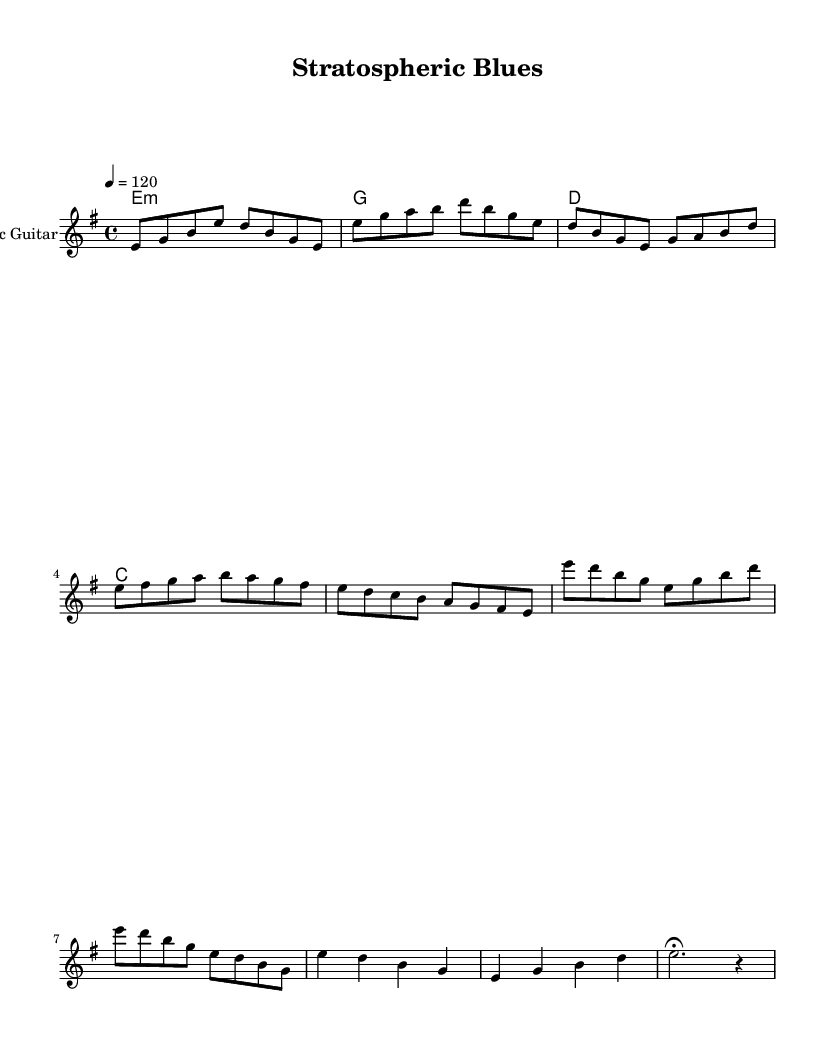What is the key signature of this music? The key signature is identified by the notes within the music. Here, the key signature is indicated as E minor, typically signified by one sharp (F#) that is often implied rather than explicitly stated in the music.
Answer: E minor What is the time signature of this music? The time signature can be identified at the beginning of the sheet music, indicated by the numbers showing how many beats are in each measure, which in this case is 4 over 4, meaning there are four beats per measure.
Answer: 4/4 What is the tempo marking for this piece? The tempo marking is stated as "4 = 120," which indicates that the quarter note gets a beat and the tempo is set at 120 beats per minute, providing a moderately fast pace for the piece.
Answer: 120 How many measures are in the first solo? By counting the measures in the first solo section, we see it consists of four measures, as indicated by the bar lines that separate them.
Answer: 4 What is the chord progression used in this piece? The chord names written above the staff in the section provided can be referenced to identify the chord progression, which follows the pattern E minor, G, D, and C, arranged across the music.
Answer: E minor, G, D, C What characterizes the second solo in terms of note clustering? The second solo shows a notable use of sixteenth notes, which are indicated by their fast-paced grouping in the notation. This showcases the electric guitar's ability to convey swift melodic lines that mimic the fluidity of jet engine sounds.
Answer: Use of sixteenth notes What style of music does this piece represent? The music is categorized as Electric Blues, a genre characterized by its use of electric guitar, expressive solos, and its roots in traditional blues, here reflected through soulful guitar passages.
Answer: Electric Blues 